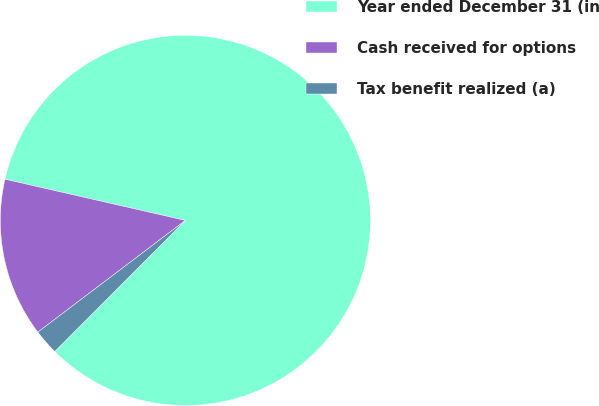Convert chart to OTSL. <chart><loc_0><loc_0><loc_500><loc_500><pie_chart><fcel>Year ended December 31 (in<fcel>Cash received for options<fcel>Tax benefit realized (a)<nl><fcel>83.9%<fcel>13.89%<fcel>2.21%<nl></chart> 